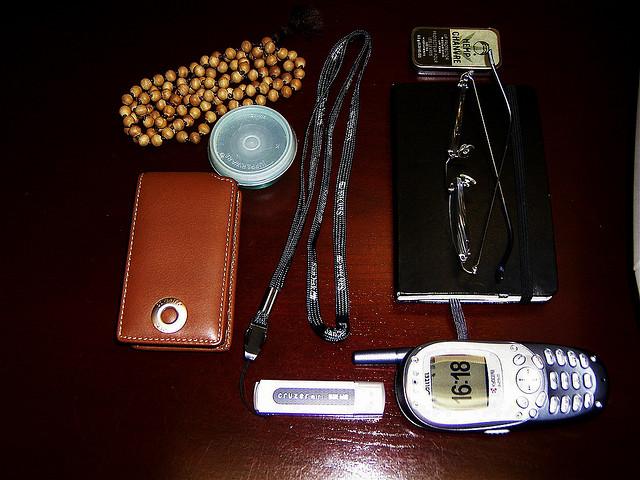The wooden beads are used for what purpose?
Concise answer only. Prayer. Are those glasses prescription glasses?
Quick response, please. Yes. What piece of technology featured in this picture stores computer files?
Quick response, please. Usb. 